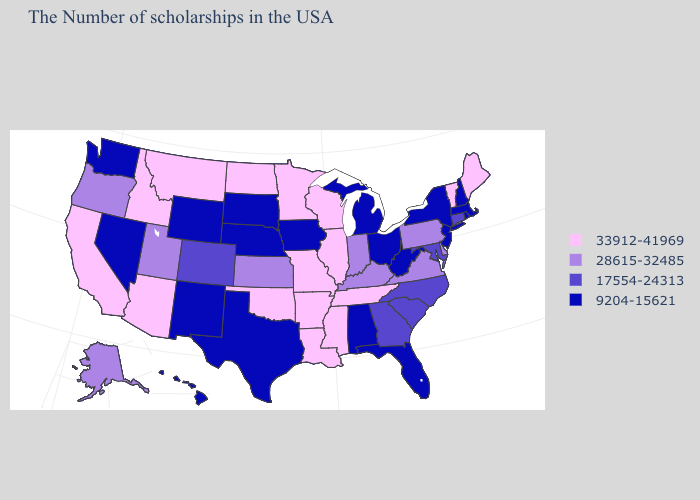Among the states that border New York , which have the highest value?
Give a very brief answer. Vermont. Name the states that have a value in the range 17554-24313?
Quick response, please. Connecticut, Maryland, North Carolina, South Carolina, Georgia, Colorado. Does Wisconsin have the highest value in the USA?
Quick response, please. Yes. What is the highest value in states that border Iowa?
Short answer required. 33912-41969. What is the value of Connecticut?
Write a very short answer. 17554-24313. Which states have the lowest value in the USA?
Give a very brief answer. Massachusetts, Rhode Island, New Hampshire, New York, New Jersey, West Virginia, Ohio, Florida, Michigan, Alabama, Iowa, Nebraska, Texas, South Dakota, Wyoming, New Mexico, Nevada, Washington, Hawaii. Name the states that have a value in the range 17554-24313?
Answer briefly. Connecticut, Maryland, North Carolina, South Carolina, Georgia, Colorado. Name the states that have a value in the range 9204-15621?
Give a very brief answer. Massachusetts, Rhode Island, New Hampshire, New York, New Jersey, West Virginia, Ohio, Florida, Michigan, Alabama, Iowa, Nebraska, Texas, South Dakota, Wyoming, New Mexico, Nevada, Washington, Hawaii. Does Pennsylvania have a higher value than Montana?
Give a very brief answer. No. What is the highest value in states that border New Mexico?
Keep it brief. 33912-41969. Does the map have missing data?
Answer briefly. No. What is the lowest value in the USA?
Be succinct. 9204-15621. What is the value of Connecticut?
Keep it brief. 17554-24313. Name the states that have a value in the range 9204-15621?
Give a very brief answer. Massachusetts, Rhode Island, New Hampshire, New York, New Jersey, West Virginia, Ohio, Florida, Michigan, Alabama, Iowa, Nebraska, Texas, South Dakota, Wyoming, New Mexico, Nevada, Washington, Hawaii. Name the states that have a value in the range 28615-32485?
Keep it brief. Delaware, Pennsylvania, Virginia, Kentucky, Indiana, Kansas, Utah, Oregon, Alaska. 